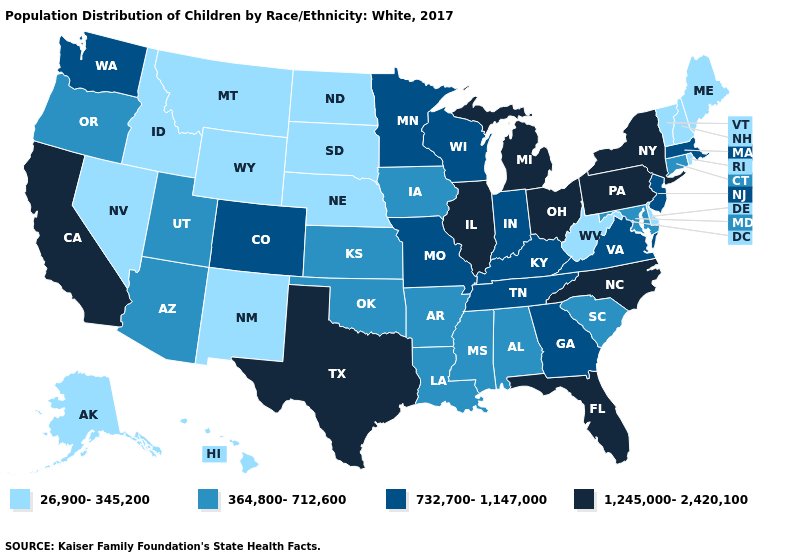Among the states that border Alabama , which have the highest value?
Keep it brief. Florida. What is the highest value in the West ?
Be succinct. 1,245,000-2,420,100. Is the legend a continuous bar?
Quick response, please. No. Which states have the lowest value in the MidWest?
Concise answer only. Nebraska, North Dakota, South Dakota. What is the value of Alaska?
Give a very brief answer. 26,900-345,200. Does Massachusetts have a higher value than New York?
Give a very brief answer. No. Name the states that have a value in the range 1,245,000-2,420,100?
Give a very brief answer. California, Florida, Illinois, Michigan, New York, North Carolina, Ohio, Pennsylvania, Texas. Does South Dakota have a lower value than Rhode Island?
Answer briefly. No. Among the states that border Ohio , does Michigan have the highest value?
Answer briefly. Yes. Which states hav the highest value in the South?
Answer briefly. Florida, North Carolina, Texas. Does the map have missing data?
Concise answer only. No. What is the highest value in states that border Minnesota?
Concise answer only. 732,700-1,147,000. Which states have the lowest value in the West?
Answer briefly. Alaska, Hawaii, Idaho, Montana, Nevada, New Mexico, Wyoming. Name the states that have a value in the range 732,700-1,147,000?
Keep it brief. Colorado, Georgia, Indiana, Kentucky, Massachusetts, Minnesota, Missouri, New Jersey, Tennessee, Virginia, Washington, Wisconsin. Name the states that have a value in the range 1,245,000-2,420,100?
Concise answer only. California, Florida, Illinois, Michigan, New York, North Carolina, Ohio, Pennsylvania, Texas. 